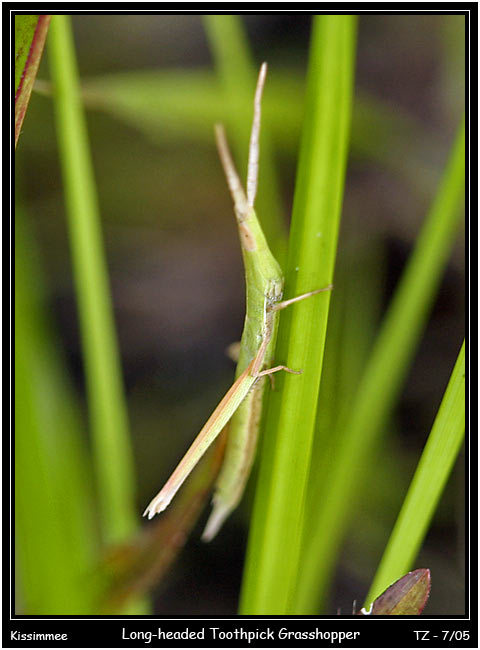Your task is to identify the object category of a real-world image. The image can contain different objects like an American flag, bear, cake, and more. Analyze the shape, color, and texture of the object to determine its category. Consider the specific details of the label. Provide the name of the object based on your classification. Upon close inspection of the image, the subject is identified as a 'Long-headed Toothpick Grasshopper'. This unique grasshopper species boasts an impressive adaptation for survival—its slender, almost stick-like form and green hue provide excellent camouflage against the backdrop of similar-sized plant stems and leaves in its natural habitat. This cunning mimicry is an evolutionary response to predation, making it difficult for both prey and predators to spot. The ‘Long-headed’ attribute refers to the distinctive elongated shape of the grasshopper's head, which further aids in its disguise among narrow foliage. The precise naming found on the label affirms its distinct biological and aesthetic features, perfectly categorizing this remarkable insect. 